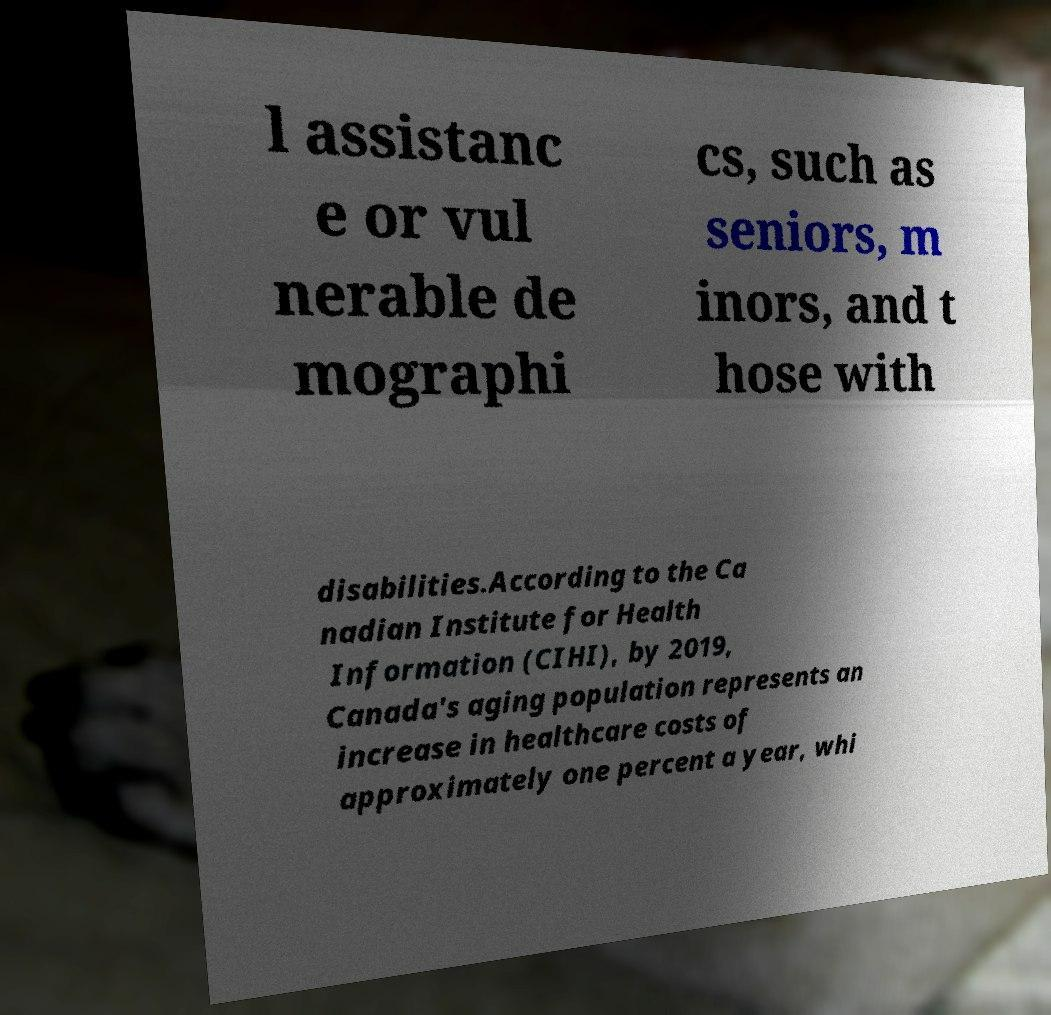Can you accurately transcribe the text from the provided image for me? l assistanc e or vul nerable de mographi cs, such as seniors, m inors, and t hose with disabilities.According to the Ca nadian Institute for Health Information (CIHI), by 2019, Canada's aging population represents an increase in healthcare costs of approximately one percent a year, whi 